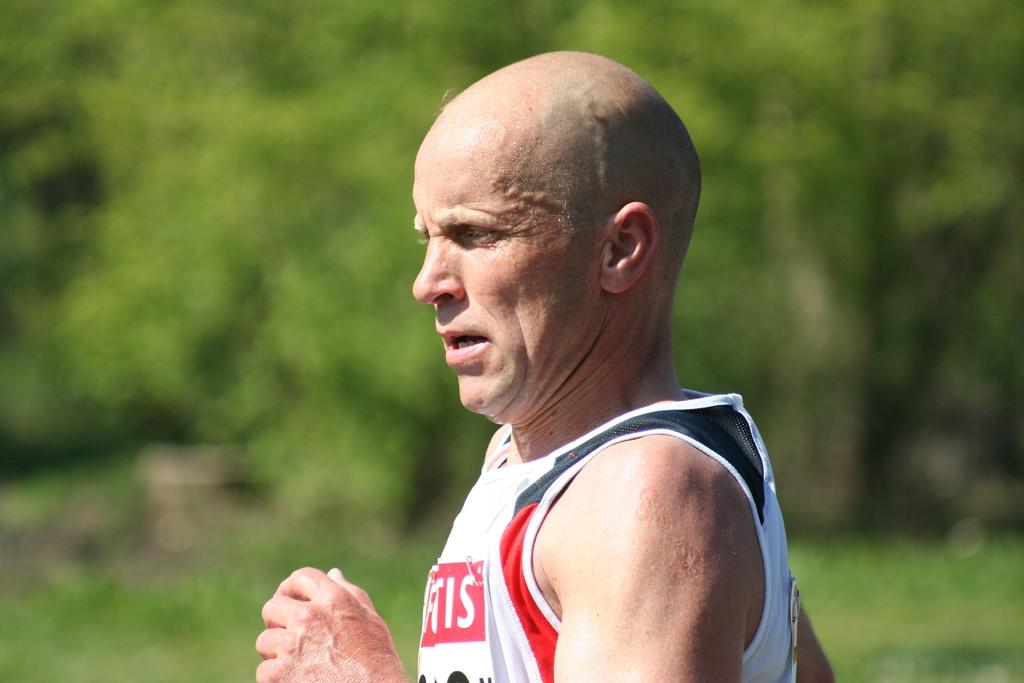<image>
Write a terse but informative summary of the picture. A older caucasian man running wearing a white shirt with the letters IS. 